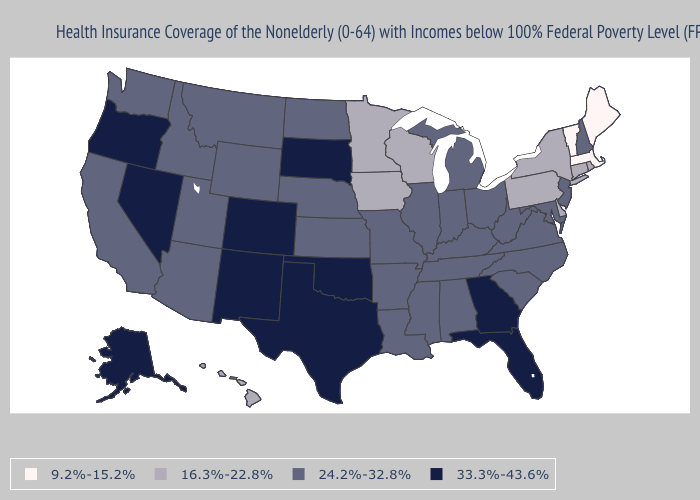Does California have the highest value in the USA?
Answer briefly. No. What is the lowest value in the USA?
Concise answer only. 9.2%-15.2%. Among the states that border West Virginia , which have the highest value?
Quick response, please. Kentucky, Maryland, Ohio, Virginia. Does the first symbol in the legend represent the smallest category?
Give a very brief answer. Yes. Which states have the lowest value in the USA?
Keep it brief. Maine, Massachusetts, Vermont. Name the states that have a value in the range 24.2%-32.8%?
Give a very brief answer. Alabama, Arizona, Arkansas, California, Idaho, Illinois, Indiana, Kansas, Kentucky, Louisiana, Maryland, Michigan, Mississippi, Missouri, Montana, Nebraska, New Hampshire, New Jersey, North Carolina, North Dakota, Ohio, South Carolina, Tennessee, Utah, Virginia, Washington, West Virginia, Wyoming. Which states hav the highest value in the Northeast?
Give a very brief answer. New Hampshire, New Jersey. Does Nevada have the highest value in the West?
Keep it brief. Yes. Among the states that border Idaho , which have the lowest value?
Give a very brief answer. Montana, Utah, Washington, Wyoming. Name the states that have a value in the range 24.2%-32.8%?
Short answer required. Alabama, Arizona, Arkansas, California, Idaho, Illinois, Indiana, Kansas, Kentucky, Louisiana, Maryland, Michigan, Mississippi, Missouri, Montana, Nebraska, New Hampshire, New Jersey, North Carolina, North Dakota, Ohio, South Carolina, Tennessee, Utah, Virginia, Washington, West Virginia, Wyoming. Name the states that have a value in the range 16.3%-22.8%?
Quick response, please. Connecticut, Delaware, Hawaii, Iowa, Minnesota, New York, Pennsylvania, Rhode Island, Wisconsin. What is the lowest value in the USA?
Be succinct. 9.2%-15.2%. What is the value of New Mexico?
Quick response, please. 33.3%-43.6%. What is the value of North Carolina?
Concise answer only. 24.2%-32.8%. What is the value of Alaska?
Write a very short answer. 33.3%-43.6%. 